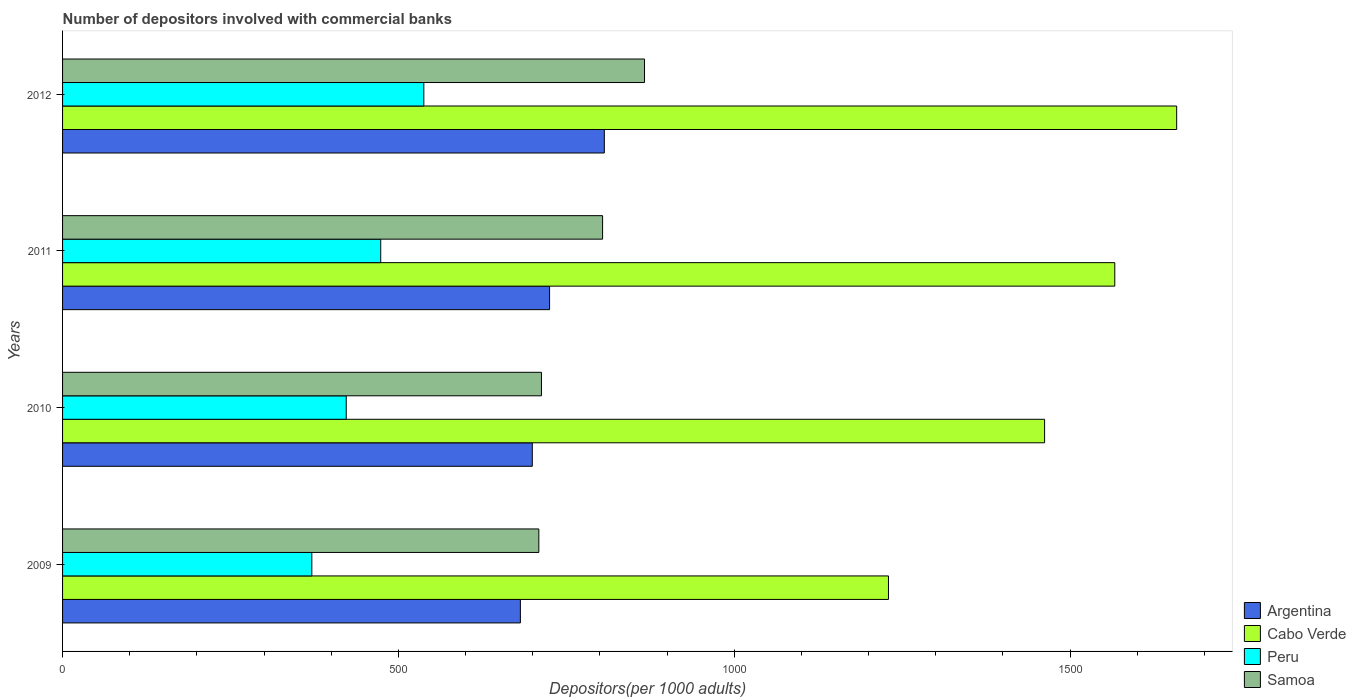Are the number of bars per tick equal to the number of legend labels?
Make the answer very short. Yes. Are the number of bars on each tick of the Y-axis equal?
Your answer should be compact. Yes. How many bars are there on the 1st tick from the top?
Keep it short and to the point. 4. In how many cases, is the number of bars for a given year not equal to the number of legend labels?
Offer a terse response. 0. What is the number of depositors involved with commercial banks in Samoa in 2011?
Offer a terse response. 804.04. Across all years, what is the maximum number of depositors involved with commercial banks in Cabo Verde?
Keep it short and to the point. 1658.79. Across all years, what is the minimum number of depositors involved with commercial banks in Argentina?
Provide a succinct answer. 681.62. In which year was the number of depositors involved with commercial banks in Samoa maximum?
Offer a terse response. 2012. What is the total number of depositors involved with commercial banks in Peru in the graph?
Offer a very short reply. 1805.03. What is the difference between the number of depositors involved with commercial banks in Argentina in 2009 and that in 2012?
Provide a succinct answer. -125.01. What is the difference between the number of depositors involved with commercial banks in Argentina in 2010 and the number of depositors involved with commercial banks in Cabo Verde in 2011?
Provide a short and direct response. -867.25. What is the average number of depositors involved with commercial banks in Peru per year?
Give a very brief answer. 451.26. In the year 2012, what is the difference between the number of depositors involved with commercial banks in Peru and number of depositors involved with commercial banks in Argentina?
Your answer should be compact. -268.76. In how many years, is the number of depositors involved with commercial banks in Samoa greater than 300 ?
Your response must be concise. 4. What is the ratio of the number of depositors involved with commercial banks in Samoa in 2009 to that in 2010?
Provide a short and direct response. 0.99. Is the number of depositors involved with commercial banks in Argentina in 2009 less than that in 2011?
Ensure brevity in your answer.  Yes. What is the difference between the highest and the second highest number of depositors involved with commercial banks in Cabo Verde?
Provide a succinct answer. 92.17. What is the difference between the highest and the lowest number of depositors involved with commercial banks in Cabo Verde?
Make the answer very short. 429.1. In how many years, is the number of depositors involved with commercial banks in Argentina greater than the average number of depositors involved with commercial banks in Argentina taken over all years?
Your response must be concise. 1. Is the sum of the number of depositors involved with commercial banks in Peru in 2010 and 2011 greater than the maximum number of depositors involved with commercial banks in Cabo Verde across all years?
Make the answer very short. No. Is it the case that in every year, the sum of the number of depositors involved with commercial banks in Peru and number of depositors involved with commercial banks in Cabo Verde is greater than the sum of number of depositors involved with commercial banks in Samoa and number of depositors involved with commercial banks in Argentina?
Provide a short and direct response. Yes. What does the 4th bar from the top in 2010 represents?
Your response must be concise. Argentina. What does the 1st bar from the bottom in 2011 represents?
Ensure brevity in your answer.  Argentina. Is it the case that in every year, the sum of the number of depositors involved with commercial banks in Cabo Verde and number of depositors involved with commercial banks in Peru is greater than the number of depositors involved with commercial banks in Argentina?
Keep it short and to the point. Yes. How many bars are there?
Give a very brief answer. 16. What is the difference between two consecutive major ticks on the X-axis?
Ensure brevity in your answer.  500. Does the graph contain grids?
Make the answer very short. No. How many legend labels are there?
Offer a very short reply. 4. What is the title of the graph?
Keep it short and to the point. Number of depositors involved with commercial banks. Does "Papua New Guinea" appear as one of the legend labels in the graph?
Make the answer very short. No. What is the label or title of the X-axis?
Your response must be concise. Depositors(per 1000 adults). What is the label or title of the Y-axis?
Offer a very short reply. Years. What is the Depositors(per 1000 adults) of Argentina in 2009?
Your answer should be compact. 681.62. What is the Depositors(per 1000 adults) in Cabo Verde in 2009?
Make the answer very short. 1229.69. What is the Depositors(per 1000 adults) in Peru in 2009?
Make the answer very short. 371.13. What is the Depositors(per 1000 adults) in Samoa in 2009?
Give a very brief answer. 709.09. What is the Depositors(per 1000 adults) of Argentina in 2010?
Give a very brief answer. 699.37. What is the Depositors(per 1000 adults) of Cabo Verde in 2010?
Make the answer very short. 1462.14. What is the Depositors(per 1000 adults) in Peru in 2010?
Your answer should be very brief. 422.34. What is the Depositors(per 1000 adults) in Samoa in 2010?
Ensure brevity in your answer.  713.02. What is the Depositors(per 1000 adults) of Argentina in 2011?
Your response must be concise. 725.1. What is the Depositors(per 1000 adults) in Cabo Verde in 2011?
Offer a very short reply. 1566.62. What is the Depositors(per 1000 adults) in Peru in 2011?
Your answer should be compact. 473.69. What is the Depositors(per 1000 adults) in Samoa in 2011?
Make the answer very short. 804.04. What is the Depositors(per 1000 adults) in Argentina in 2012?
Your answer should be compact. 806.63. What is the Depositors(per 1000 adults) of Cabo Verde in 2012?
Provide a succinct answer. 1658.79. What is the Depositors(per 1000 adults) in Peru in 2012?
Your response must be concise. 537.87. What is the Depositors(per 1000 adults) of Samoa in 2012?
Offer a very short reply. 866.45. Across all years, what is the maximum Depositors(per 1000 adults) of Argentina?
Offer a terse response. 806.63. Across all years, what is the maximum Depositors(per 1000 adults) in Cabo Verde?
Make the answer very short. 1658.79. Across all years, what is the maximum Depositors(per 1000 adults) in Peru?
Your response must be concise. 537.87. Across all years, what is the maximum Depositors(per 1000 adults) of Samoa?
Your response must be concise. 866.45. Across all years, what is the minimum Depositors(per 1000 adults) in Argentina?
Your response must be concise. 681.62. Across all years, what is the minimum Depositors(per 1000 adults) of Cabo Verde?
Offer a very short reply. 1229.69. Across all years, what is the minimum Depositors(per 1000 adults) of Peru?
Your answer should be very brief. 371.13. Across all years, what is the minimum Depositors(per 1000 adults) in Samoa?
Offer a very short reply. 709.09. What is the total Depositors(per 1000 adults) of Argentina in the graph?
Offer a terse response. 2912.72. What is the total Depositors(per 1000 adults) in Cabo Verde in the graph?
Your response must be concise. 5917.23. What is the total Depositors(per 1000 adults) of Peru in the graph?
Your answer should be very brief. 1805.03. What is the total Depositors(per 1000 adults) of Samoa in the graph?
Provide a succinct answer. 3092.61. What is the difference between the Depositors(per 1000 adults) in Argentina in 2009 and that in 2010?
Provide a succinct answer. -17.75. What is the difference between the Depositors(per 1000 adults) in Cabo Verde in 2009 and that in 2010?
Offer a terse response. -232.45. What is the difference between the Depositors(per 1000 adults) of Peru in 2009 and that in 2010?
Make the answer very short. -51.21. What is the difference between the Depositors(per 1000 adults) of Samoa in 2009 and that in 2010?
Offer a very short reply. -3.93. What is the difference between the Depositors(per 1000 adults) of Argentina in 2009 and that in 2011?
Provide a short and direct response. -43.48. What is the difference between the Depositors(per 1000 adults) in Cabo Verde in 2009 and that in 2011?
Your answer should be very brief. -336.94. What is the difference between the Depositors(per 1000 adults) of Peru in 2009 and that in 2011?
Give a very brief answer. -102.56. What is the difference between the Depositors(per 1000 adults) of Samoa in 2009 and that in 2011?
Offer a terse response. -94.95. What is the difference between the Depositors(per 1000 adults) in Argentina in 2009 and that in 2012?
Give a very brief answer. -125.01. What is the difference between the Depositors(per 1000 adults) of Cabo Verde in 2009 and that in 2012?
Your answer should be compact. -429.1. What is the difference between the Depositors(per 1000 adults) in Peru in 2009 and that in 2012?
Ensure brevity in your answer.  -166.74. What is the difference between the Depositors(per 1000 adults) in Samoa in 2009 and that in 2012?
Give a very brief answer. -157.36. What is the difference between the Depositors(per 1000 adults) in Argentina in 2010 and that in 2011?
Provide a short and direct response. -25.73. What is the difference between the Depositors(per 1000 adults) in Cabo Verde in 2010 and that in 2011?
Make the answer very short. -104.49. What is the difference between the Depositors(per 1000 adults) of Peru in 2010 and that in 2011?
Give a very brief answer. -51.35. What is the difference between the Depositors(per 1000 adults) in Samoa in 2010 and that in 2011?
Ensure brevity in your answer.  -91.03. What is the difference between the Depositors(per 1000 adults) of Argentina in 2010 and that in 2012?
Give a very brief answer. -107.26. What is the difference between the Depositors(per 1000 adults) in Cabo Verde in 2010 and that in 2012?
Keep it short and to the point. -196.65. What is the difference between the Depositors(per 1000 adults) of Peru in 2010 and that in 2012?
Ensure brevity in your answer.  -115.53. What is the difference between the Depositors(per 1000 adults) in Samoa in 2010 and that in 2012?
Your response must be concise. -153.43. What is the difference between the Depositors(per 1000 adults) in Argentina in 2011 and that in 2012?
Offer a terse response. -81.53. What is the difference between the Depositors(per 1000 adults) in Cabo Verde in 2011 and that in 2012?
Provide a short and direct response. -92.17. What is the difference between the Depositors(per 1000 adults) of Peru in 2011 and that in 2012?
Ensure brevity in your answer.  -64.18. What is the difference between the Depositors(per 1000 adults) of Samoa in 2011 and that in 2012?
Make the answer very short. -62.41. What is the difference between the Depositors(per 1000 adults) in Argentina in 2009 and the Depositors(per 1000 adults) in Cabo Verde in 2010?
Provide a short and direct response. -780.52. What is the difference between the Depositors(per 1000 adults) in Argentina in 2009 and the Depositors(per 1000 adults) in Peru in 2010?
Offer a very short reply. 259.28. What is the difference between the Depositors(per 1000 adults) of Argentina in 2009 and the Depositors(per 1000 adults) of Samoa in 2010?
Keep it short and to the point. -31.4. What is the difference between the Depositors(per 1000 adults) in Cabo Verde in 2009 and the Depositors(per 1000 adults) in Peru in 2010?
Your answer should be very brief. 807.34. What is the difference between the Depositors(per 1000 adults) of Cabo Verde in 2009 and the Depositors(per 1000 adults) of Samoa in 2010?
Ensure brevity in your answer.  516.67. What is the difference between the Depositors(per 1000 adults) in Peru in 2009 and the Depositors(per 1000 adults) in Samoa in 2010?
Offer a very short reply. -341.89. What is the difference between the Depositors(per 1000 adults) in Argentina in 2009 and the Depositors(per 1000 adults) in Cabo Verde in 2011?
Keep it short and to the point. -885. What is the difference between the Depositors(per 1000 adults) of Argentina in 2009 and the Depositors(per 1000 adults) of Peru in 2011?
Your answer should be compact. 207.93. What is the difference between the Depositors(per 1000 adults) in Argentina in 2009 and the Depositors(per 1000 adults) in Samoa in 2011?
Give a very brief answer. -122.43. What is the difference between the Depositors(per 1000 adults) of Cabo Verde in 2009 and the Depositors(per 1000 adults) of Peru in 2011?
Give a very brief answer. 756. What is the difference between the Depositors(per 1000 adults) of Cabo Verde in 2009 and the Depositors(per 1000 adults) of Samoa in 2011?
Your answer should be very brief. 425.64. What is the difference between the Depositors(per 1000 adults) of Peru in 2009 and the Depositors(per 1000 adults) of Samoa in 2011?
Provide a short and direct response. -432.91. What is the difference between the Depositors(per 1000 adults) in Argentina in 2009 and the Depositors(per 1000 adults) in Cabo Verde in 2012?
Make the answer very short. -977.17. What is the difference between the Depositors(per 1000 adults) in Argentina in 2009 and the Depositors(per 1000 adults) in Peru in 2012?
Offer a terse response. 143.75. What is the difference between the Depositors(per 1000 adults) in Argentina in 2009 and the Depositors(per 1000 adults) in Samoa in 2012?
Give a very brief answer. -184.83. What is the difference between the Depositors(per 1000 adults) of Cabo Verde in 2009 and the Depositors(per 1000 adults) of Peru in 2012?
Keep it short and to the point. 691.82. What is the difference between the Depositors(per 1000 adults) of Cabo Verde in 2009 and the Depositors(per 1000 adults) of Samoa in 2012?
Keep it short and to the point. 363.23. What is the difference between the Depositors(per 1000 adults) in Peru in 2009 and the Depositors(per 1000 adults) in Samoa in 2012?
Provide a succinct answer. -495.32. What is the difference between the Depositors(per 1000 adults) of Argentina in 2010 and the Depositors(per 1000 adults) of Cabo Verde in 2011?
Your response must be concise. -867.25. What is the difference between the Depositors(per 1000 adults) in Argentina in 2010 and the Depositors(per 1000 adults) in Peru in 2011?
Ensure brevity in your answer.  225.68. What is the difference between the Depositors(per 1000 adults) of Argentina in 2010 and the Depositors(per 1000 adults) of Samoa in 2011?
Offer a terse response. -104.67. What is the difference between the Depositors(per 1000 adults) of Cabo Verde in 2010 and the Depositors(per 1000 adults) of Peru in 2011?
Your response must be concise. 988.45. What is the difference between the Depositors(per 1000 adults) of Cabo Verde in 2010 and the Depositors(per 1000 adults) of Samoa in 2011?
Make the answer very short. 658.09. What is the difference between the Depositors(per 1000 adults) in Peru in 2010 and the Depositors(per 1000 adults) in Samoa in 2011?
Provide a succinct answer. -381.7. What is the difference between the Depositors(per 1000 adults) of Argentina in 2010 and the Depositors(per 1000 adults) of Cabo Verde in 2012?
Make the answer very short. -959.42. What is the difference between the Depositors(per 1000 adults) in Argentina in 2010 and the Depositors(per 1000 adults) in Peru in 2012?
Offer a terse response. 161.5. What is the difference between the Depositors(per 1000 adults) of Argentina in 2010 and the Depositors(per 1000 adults) of Samoa in 2012?
Give a very brief answer. -167.08. What is the difference between the Depositors(per 1000 adults) in Cabo Verde in 2010 and the Depositors(per 1000 adults) in Peru in 2012?
Keep it short and to the point. 924.26. What is the difference between the Depositors(per 1000 adults) in Cabo Verde in 2010 and the Depositors(per 1000 adults) in Samoa in 2012?
Your answer should be compact. 595.68. What is the difference between the Depositors(per 1000 adults) of Peru in 2010 and the Depositors(per 1000 adults) of Samoa in 2012?
Provide a short and direct response. -444.11. What is the difference between the Depositors(per 1000 adults) in Argentina in 2011 and the Depositors(per 1000 adults) in Cabo Verde in 2012?
Keep it short and to the point. -933.68. What is the difference between the Depositors(per 1000 adults) in Argentina in 2011 and the Depositors(per 1000 adults) in Peru in 2012?
Make the answer very short. 187.23. What is the difference between the Depositors(per 1000 adults) in Argentina in 2011 and the Depositors(per 1000 adults) in Samoa in 2012?
Offer a terse response. -141.35. What is the difference between the Depositors(per 1000 adults) in Cabo Verde in 2011 and the Depositors(per 1000 adults) in Peru in 2012?
Your answer should be very brief. 1028.75. What is the difference between the Depositors(per 1000 adults) of Cabo Verde in 2011 and the Depositors(per 1000 adults) of Samoa in 2012?
Offer a terse response. 700.17. What is the difference between the Depositors(per 1000 adults) of Peru in 2011 and the Depositors(per 1000 adults) of Samoa in 2012?
Offer a terse response. -392.76. What is the average Depositors(per 1000 adults) of Argentina per year?
Your answer should be compact. 728.18. What is the average Depositors(per 1000 adults) of Cabo Verde per year?
Offer a terse response. 1479.31. What is the average Depositors(per 1000 adults) of Peru per year?
Give a very brief answer. 451.26. What is the average Depositors(per 1000 adults) of Samoa per year?
Your response must be concise. 773.15. In the year 2009, what is the difference between the Depositors(per 1000 adults) of Argentina and Depositors(per 1000 adults) of Cabo Verde?
Make the answer very short. -548.07. In the year 2009, what is the difference between the Depositors(per 1000 adults) in Argentina and Depositors(per 1000 adults) in Peru?
Ensure brevity in your answer.  310.49. In the year 2009, what is the difference between the Depositors(per 1000 adults) in Argentina and Depositors(per 1000 adults) in Samoa?
Give a very brief answer. -27.47. In the year 2009, what is the difference between the Depositors(per 1000 adults) in Cabo Verde and Depositors(per 1000 adults) in Peru?
Offer a terse response. 858.55. In the year 2009, what is the difference between the Depositors(per 1000 adults) in Cabo Verde and Depositors(per 1000 adults) in Samoa?
Give a very brief answer. 520.59. In the year 2009, what is the difference between the Depositors(per 1000 adults) in Peru and Depositors(per 1000 adults) in Samoa?
Give a very brief answer. -337.96. In the year 2010, what is the difference between the Depositors(per 1000 adults) in Argentina and Depositors(per 1000 adults) in Cabo Verde?
Make the answer very short. -762.76. In the year 2010, what is the difference between the Depositors(per 1000 adults) in Argentina and Depositors(per 1000 adults) in Peru?
Provide a short and direct response. 277.03. In the year 2010, what is the difference between the Depositors(per 1000 adults) in Argentina and Depositors(per 1000 adults) in Samoa?
Provide a succinct answer. -13.65. In the year 2010, what is the difference between the Depositors(per 1000 adults) in Cabo Verde and Depositors(per 1000 adults) in Peru?
Your answer should be compact. 1039.79. In the year 2010, what is the difference between the Depositors(per 1000 adults) of Cabo Verde and Depositors(per 1000 adults) of Samoa?
Make the answer very short. 749.12. In the year 2010, what is the difference between the Depositors(per 1000 adults) in Peru and Depositors(per 1000 adults) in Samoa?
Keep it short and to the point. -290.68. In the year 2011, what is the difference between the Depositors(per 1000 adults) of Argentina and Depositors(per 1000 adults) of Cabo Verde?
Your answer should be very brief. -841.52. In the year 2011, what is the difference between the Depositors(per 1000 adults) of Argentina and Depositors(per 1000 adults) of Peru?
Offer a very short reply. 251.41. In the year 2011, what is the difference between the Depositors(per 1000 adults) of Argentina and Depositors(per 1000 adults) of Samoa?
Give a very brief answer. -78.94. In the year 2011, what is the difference between the Depositors(per 1000 adults) of Cabo Verde and Depositors(per 1000 adults) of Peru?
Ensure brevity in your answer.  1092.93. In the year 2011, what is the difference between the Depositors(per 1000 adults) in Cabo Verde and Depositors(per 1000 adults) in Samoa?
Keep it short and to the point. 762.58. In the year 2011, what is the difference between the Depositors(per 1000 adults) in Peru and Depositors(per 1000 adults) in Samoa?
Your response must be concise. -330.35. In the year 2012, what is the difference between the Depositors(per 1000 adults) in Argentina and Depositors(per 1000 adults) in Cabo Verde?
Offer a very short reply. -852.16. In the year 2012, what is the difference between the Depositors(per 1000 adults) in Argentina and Depositors(per 1000 adults) in Peru?
Offer a terse response. 268.76. In the year 2012, what is the difference between the Depositors(per 1000 adults) of Argentina and Depositors(per 1000 adults) of Samoa?
Provide a short and direct response. -59.82. In the year 2012, what is the difference between the Depositors(per 1000 adults) in Cabo Verde and Depositors(per 1000 adults) in Peru?
Provide a succinct answer. 1120.92. In the year 2012, what is the difference between the Depositors(per 1000 adults) in Cabo Verde and Depositors(per 1000 adults) in Samoa?
Give a very brief answer. 792.34. In the year 2012, what is the difference between the Depositors(per 1000 adults) in Peru and Depositors(per 1000 adults) in Samoa?
Provide a succinct answer. -328.58. What is the ratio of the Depositors(per 1000 adults) in Argentina in 2009 to that in 2010?
Provide a short and direct response. 0.97. What is the ratio of the Depositors(per 1000 adults) in Cabo Verde in 2009 to that in 2010?
Provide a short and direct response. 0.84. What is the ratio of the Depositors(per 1000 adults) in Peru in 2009 to that in 2010?
Keep it short and to the point. 0.88. What is the ratio of the Depositors(per 1000 adults) of Samoa in 2009 to that in 2010?
Keep it short and to the point. 0.99. What is the ratio of the Depositors(per 1000 adults) of Argentina in 2009 to that in 2011?
Give a very brief answer. 0.94. What is the ratio of the Depositors(per 1000 adults) in Cabo Verde in 2009 to that in 2011?
Offer a terse response. 0.78. What is the ratio of the Depositors(per 1000 adults) in Peru in 2009 to that in 2011?
Offer a very short reply. 0.78. What is the ratio of the Depositors(per 1000 adults) of Samoa in 2009 to that in 2011?
Offer a terse response. 0.88. What is the ratio of the Depositors(per 1000 adults) in Argentina in 2009 to that in 2012?
Give a very brief answer. 0.84. What is the ratio of the Depositors(per 1000 adults) of Cabo Verde in 2009 to that in 2012?
Your answer should be compact. 0.74. What is the ratio of the Depositors(per 1000 adults) in Peru in 2009 to that in 2012?
Offer a terse response. 0.69. What is the ratio of the Depositors(per 1000 adults) in Samoa in 2009 to that in 2012?
Offer a very short reply. 0.82. What is the ratio of the Depositors(per 1000 adults) in Argentina in 2010 to that in 2011?
Your response must be concise. 0.96. What is the ratio of the Depositors(per 1000 adults) of Peru in 2010 to that in 2011?
Make the answer very short. 0.89. What is the ratio of the Depositors(per 1000 adults) in Samoa in 2010 to that in 2011?
Ensure brevity in your answer.  0.89. What is the ratio of the Depositors(per 1000 adults) in Argentina in 2010 to that in 2012?
Give a very brief answer. 0.87. What is the ratio of the Depositors(per 1000 adults) in Cabo Verde in 2010 to that in 2012?
Your answer should be very brief. 0.88. What is the ratio of the Depositors(per 1000 adults) in Peru in 2010 to that in 2012?
Keep it short and to the point. 0.79. What is the ratio of the Depositors(per 1000 adults) in Samoa in 2010 to that in 2012?
Keep it short and to the point. 0.82. What is the ratio of the Depositors(per 1000 adults) in Argentina in 2011 to that in 2012?
Your answer should be compact. 0.9. What is the ratio of the Depositors(per 1000 adults) in Peru in 2011 to that in 2012?
Provide a succinct answer. 0.88. What is the ratio of the Depositors(per 1000 adults) in Samoa in 2011 to that in 2012?
Your response must be concise. 0.93. What is the difference between the highest and the second highest Depositors(per 1000 adults) in Argentina?
Offer a terse response. 81.53. What is the difference between the highest and the second highest Depositors(per 1000 adults) of Cabo Verde?
Your response must be concise. 92.17. What is the difference between the highest and the second highest Depositors(per 1000 adults) of Peru?
Your answer should be very brief. 64.18. What is the difference between the highest and the second highest Depositors(per 1000 adults) in Samoa?
Make the answer very short. 62.41. What is the difference between the highest and the lowest Depositors(per 1000 adults) in Argentina?
Offer a very short reply. 125.01. What is the difference between the highest and the lowest Depositors(per 1000 adults) of Cabo Verde?
Offer a very short reply. 429.1. What is the difference between the highest and the lowest Depositors(per 1000 adults) of Peru?
Your response must be concise. 166.74. What is the difference between the highest and the lowest Depositors(per 1000 adults) in Samoa?
Keep it short and to the point. 157.36. 